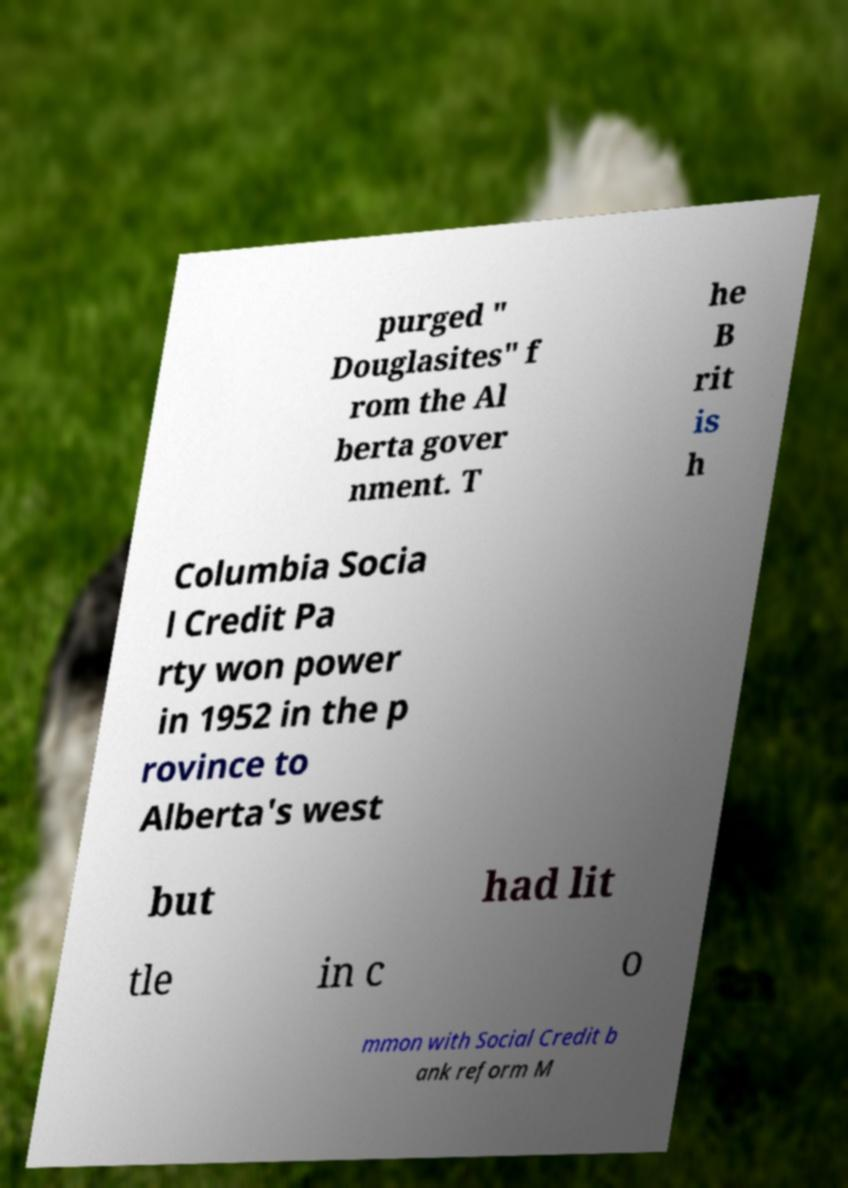Could you assist in decoding the text presented in this image and type it out clearly? purged " Douglasites" f rom the Al berta gover nment. T he B rit is h Columbia Socia l Credit Pa rty won power in 1952 in the p rovince to Alberta's west but had lit tle in c o mmon with Social Credit b ank reform M 